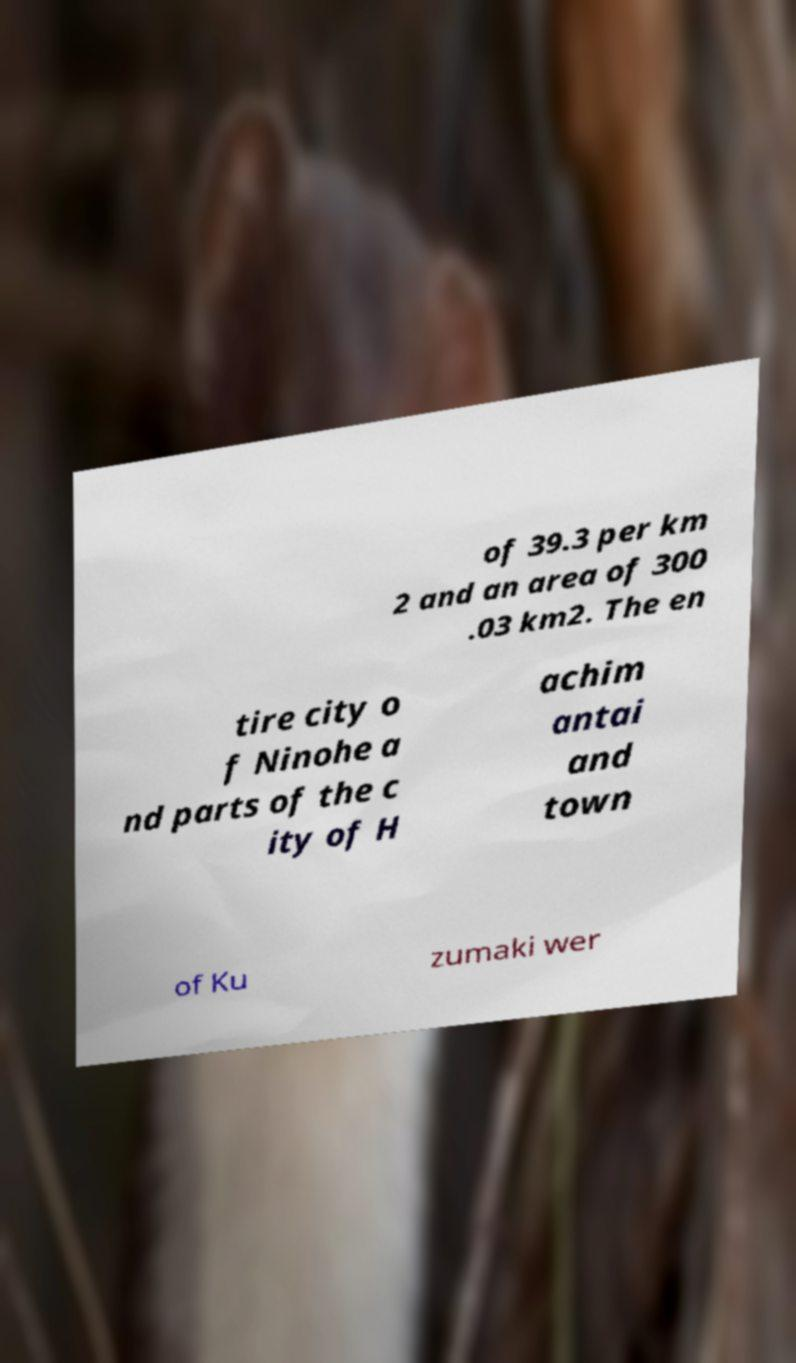Could you assist in decoding the text presented in this image and type it out clearly? of 39.3 per km 2 and an area of 300 .03 km2. The en tire city o f Ninohe a nd parts of the c ity of H achim antai and town of Ku zumaki wer 